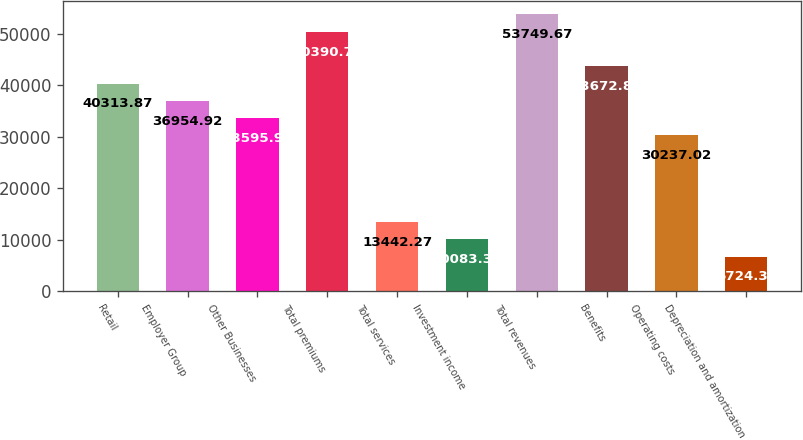Convert chart to OTSL. <chart><loc_0><loc_0><loc_500><loc_500><bar_chart><fcel>Retail<fcel>Employer Group<fcel>Other Businesses<fcel>Total premiums<fcel>Total services<fcel>Investment income<fcel>Total revenues<fcel>Benefits<fcel>Operating costs<fcel>Depreciation and amortization<nl><fcel>40313.9<fcel>36954.9<fcel>33596<fcel>50390.7<fcel>13442.3<fcel>10083.3<fcel>53749.7<fcel>43672.8<fcel>30237<fcel>6724.37<nl></chart> 